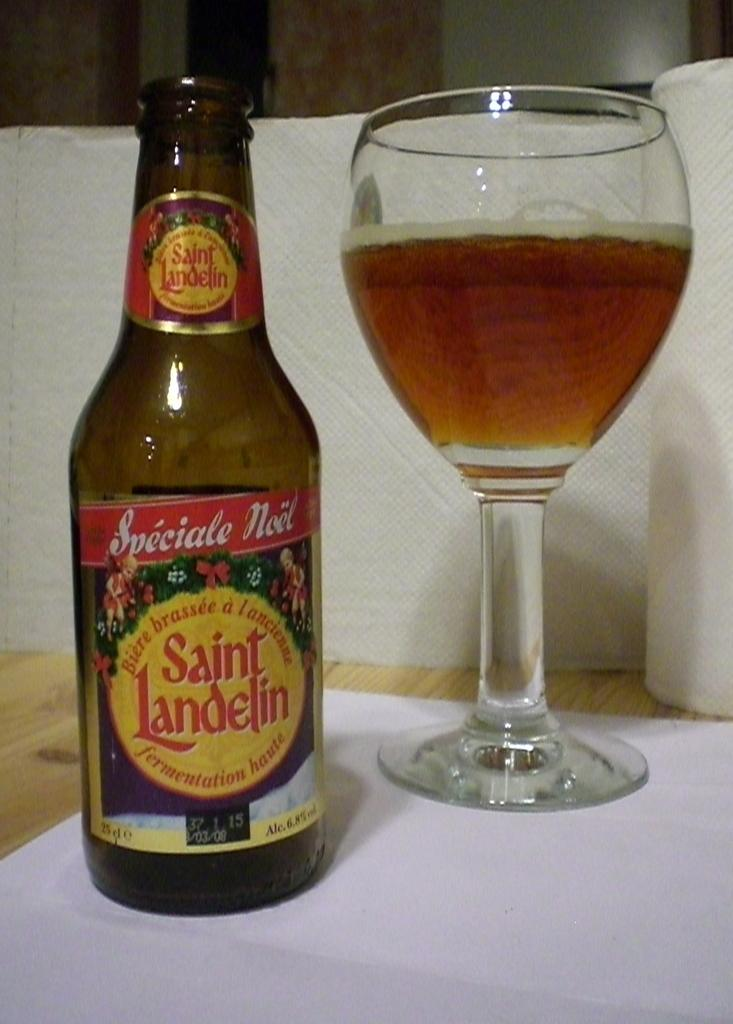What type of furniture is present in the image? There is a table in the image. What color is the table? The table is yellow. What is on the table? There is a wine bottle and a glass on the table. What color is the wine bottle? The wine bottle is brown. What is in the glass on the table? The glass contains wine. What type of behavior does the beetle exhibit in the image? There is no beetle present in the image, so it is not possible to describe its behavior. 